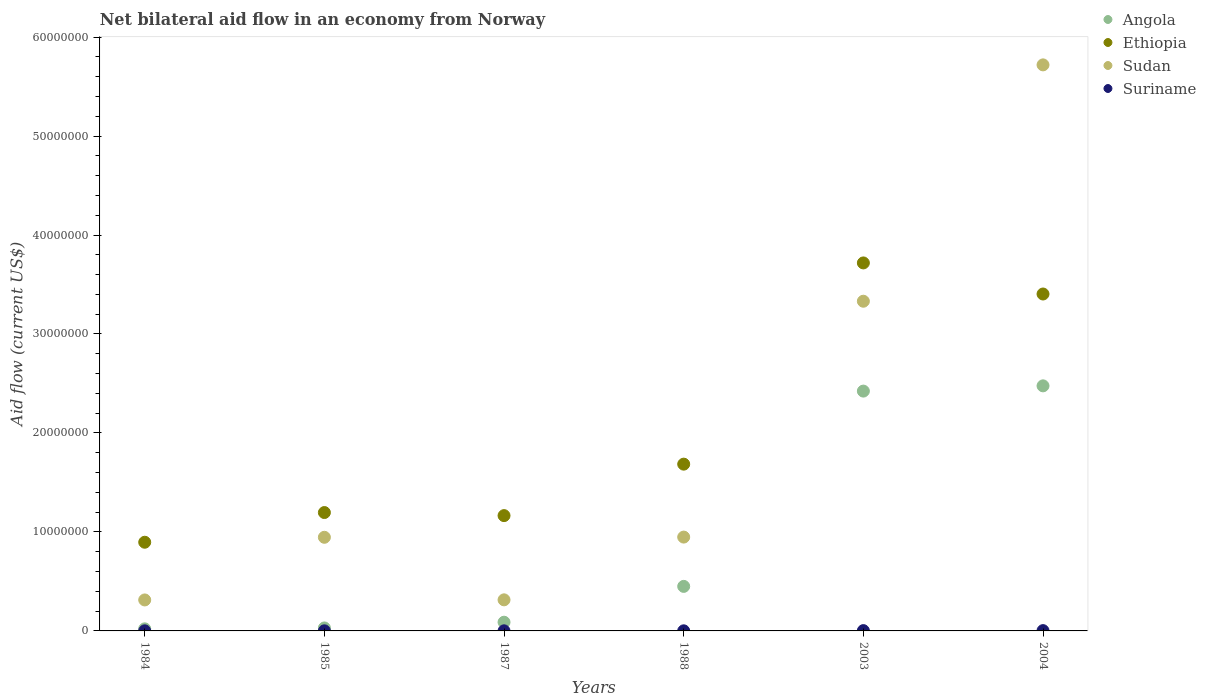How many different coloured dotlines are there?
Ensure brevity in your answer.  4. What is the net bilateral aid flow in Ethiopia in 1988?
Offer a very short reply. 1.68e+07. Across all years, what is the maximum net bilateral aid flow in Suriname?
Your answer should be compact. 3.00e+04. Across all years, what is the minimum net bilateral aid flow in Sudan?
Your response must be concise. 3.13e+06. In which year was the net bilateral aid flow in Ethiopia maximum?
Give a very brief answer. 2003. What is the total net bilateral aid flow in Ethiopia in the graph?
Give a very brief answer. 1.21e+08. What is the difference between the net bilateral aid flow in Suriname in 1984 and that in 1985?
Your answer should be very brief. 0. What is the difference between the net bilateral aid flow in Ethiopia in 2003 and the net bilateral aid flow in Sudan in 1987?
Provide a short and direct response. 3.40e+07. What is the average net bilateral aid flow in Angola per year?
Make the answer very short. 9.15e+06. In the year 2004, what is the difference between the net bilateral aid flow in Ethiopia and net bilateral aid flow in Sudan?
Make the answer very short. -2.32e+07. What is the ratio of the net bilateral aid flow in Sudan in 1984 to that in 1987?
Provide a short and direct response. 1. What is the difference between the highest and the second highest net bilateral aid flow in Angola?
Your response must be concise. 5.30e+05. What is the difference between the highest and the lowest net bilateral aid flow in Suriname?
Your answer should be very brief. 2.00e+04. In how many years, is the net bilateral aid flow in Suriname greater than the average net bilateral aid flow in Suriname taken over all years?
Ensure brevity in your answer.  2. Is it the case that in every year, the sum of the net bilateral aid flow in Sudan and net bilateral aid flow in Angola  is greater than the sum of net bilateral aid flow in Suriname and net bilateral aid flow in Ethiopia?
Your answer should be compact. No. Is it the case that in every year, the sum of the net bilateral aid flow in Suriname and net bilateral aid flow in Sudan  is greater than the net bilateral aid flow in Ethiopia?
Ensure brevity in your answer.  No. Does the net bilateral aid flow in Sudan monotonically increase over the years?
Offer a terse response. No. How many years are there in the graph?
Provide a short and direct response. 6. What is the difference between two consecutive major ticks on the Y-axis?
Your answer should be very brief. 1.00e+07. Are the values on the major ticks of Y-axis written in scientific E-notation?
Your answer should be compact. No. Does the graph contain grids?
Make the answer very short. No. How many legend labels are there?
Your response must be concise. 4. How are the legend labels stacked?
Keep it short and to the point. Vertical. What is the title of the graph?
Give a very brief answer. Net bilateral aid flow in an economy from Norway. Does "Malaysia" appear as one of the legend labels in the graph?
Provide a short and direct response. No. What is the label or title of the Y-axis?
Keep it short and to the point. Aid flow (current US$). What is the Aid flow (current US$) in Ethiopia in 1984?
Your answer should be compact. 8.96e+06. What is the Aid flow (current US$) of Sudan in 1984?
Your response must be concise. 3.13e+06. What is the Aid flow (current US$) in Suriname in 1984?
Provide a succinct answer. 10000. What is the Aid flow (current US$) of Angola in 1985?
Give a very brief answer. 3.00e+05. What is the Aid flow (current US$) of Ethiopia in 1985?
Make the answer very short. 1.20e+07. What is the Aid flow (current US$) in Sudan in 1985?
Your answer should be very brief. 9.46e+06. What is the Aid flow (current US$) in Suriname in 1985?
Make the answer very short. 10000. What is the Aid flow (current US$) of Angola in 1987?
Offer a very short reply. 8.80e+05. What is the Aid flow (current US$) in Ethiopia in 1987?
Keep it short and to the point. 1.16e+07. What is the Aid flow (current US$) of Sudan in 1987?
Make the answer very short. 3.14e+06. What is the Aid flow (current US$) in Suriname in 1987?
Make the answer very short. 10000. What is the Aid flow (current US$) of Angola in 1988?
Offer a terse response. 4.50e+06. What is the Aid flow (current US$) in Ethiopia in 1988?
Your answer should be very brief. 1.68e+07. What is the Aid flow (current US$) in Sudan in 1988?
Your answer should be compact. 9.48e+06. What is the Aid flow (current US$) of Suriname in 1988?
Your answer should be compact. 10000. What is the Aid flow (current US$) in Angola in 2003?
Give a very brief answer. 2.42e+07. What is the Aid flow (current US$) of Ethiopia in 2003?
Keep it short and to the point. 3.72e+07. What is the Aid flow (current US$) of Sudan in 2003?
Offer a terse response. 3.33e+07. What is the Aid flow (current US$) of Suriname in 2003?
Keep it short and to the point. 3.00e+04. What is the Aid flow (current US$) of Angola in 2004?
Your answer should be very brief. 2.48e+07. What is the Aid flow (current US$) in Ethiopia in 2004?
Offer a terse response. 3.40e+07. What is the Aid flow (current US$) in Sudan in 2004?
Ensure brevity in your answer.  5.72e+07. What is the Aid flow (current US$) in Suriname in 2004?
Offer a very short reply. 3.00e+04. Across all years, what is the maximum Aid flow (current US$) of Angola?
Make the answer very short. 2.48e+07. Across all years, what is the maximum Aid flow (current US$) in Ethiopia?
Your answer should be compact. 3.72e+07. Across all years, what is the maximum Aid flow (current US$) in Sudan?
Keep it short and to the point. 5.72e+07. Across all years, what is the minimum Aid flow (current US$) in Ethiopia?
Make the answer very short. 8.96e+06. Across all years, what is the minimum Aid flow (current US$) of Sudan?
Keep it short and to the point. 3.13e+06. What is the total Aid flow (current US$) of Angola in the graph?
Give a very brief answer. 5.49e+07. What is the total Aid flow (current US$) of Ethiopia in the graph?
Offer a very short reply. 1.21e+08. What is the total Aid flow (current US$) in Sudan in the graph?
Make the answer very short. 1.16e+08. What is the difference between the Aid flow (current US$) in Angola in 1984 and that in 1985?
Give a very brief answer. -9.00e+04. What is the difference between the Aid flow (current US$) of Sudan in 1984 and that in 1985?
Provide a succinct answer. -6.33e+06. What is the difference between the Aid flow (current US$) of Angola in 1984 and that in 1987?
Give a very brief answer. -6.70e+05. What is the difference between the Aid flow (current US$) of Ethiopia in 1984 and that in 1987?
Provide a short and direct response. -2.69e+06. What is the difference between the Aid flow (current US$) of Angola in 1984 and that in 1988?
Provide a short and direct response. -4.29e+06. What is the difference between the Aid flow (current US$) in Ethiopia in 1984 and that in 1988?
Offer a very short reply. -7.89e+06. What is the difference between the Aid flow (current US$) in Sudan in 1984 and that in 1988?
Ensure brevity in your answer.  -6.35e+06. What is the difference between the Aid flow (current US$) in Suriname in 1984 and that in 1988?
Provide a succinct answer. 0. What is the difference between the Aid flow (current US$) of Angola in 1984 and that in 2003?
Keep it short and to the point. -2.40e+07. What is the difference between the Aid flow (current US$) of Ethiopia in 1984 and that in 2003?
Make the answer very short. -2.82e+07. What is the difference between the Aid flow (current US$) of Sudan in 1984 and that in 2003?
Offer a terse response. -3.02e+07. What is the difference between the Aid flow (current US$) of Suriname in 1984 and that in 2003?
Make the answer very short. -2.00e+04. What is the difference between the Aid flow (current US$) in Angola in 1984 and that in 2004?
Ensure brevity in your answer.  -2.46e+07. What is the difference between the Aid flow (current US$) of Ethiopia in 1984 and that in 2004?
Give a very brief answer. -2.51e+07. What is the difference between the Aid flow (current US$) of Sudan in 1984 and that in 2004?
Give a very brief answer. -5.41e+07. What is the difference between the Aid flow (current US$) of Suriname in 1984 and that in 2004?
Your response must be concise. -2.00e+04. What is the difference between the Aid flow (current US$) in Angola in 1985 and that in 1987?
Your answer should be compact. -5.80e+05. What is the difference between the Aid flow (current US$) in Sudan in 1985 and that in 1987?
Keep it short and to the point. 6.32e+06. What is the difference between the Aid flow (current US$) of Angola in 1985 and that in 1988?
Provide a succinct answer. -4.20e+06. What is the difference between the Aid flow (current US$) in Ethiopia in 1985 and that in 1988?
Your response must be concise. -4.89e+06. What is the difference between the Aid flow (current US$) in Suriname in 1985 and that in 1988?
Your response must be concise. 0. What is the difference between the Aid flow (current US$) of Angola in 1985 and that in 2003?
Make the answer very short. -2.39e+07. What is the difference between the Aid flow (current US$) of Ethiopia in 1985 and that in 2003?
Your answer should be compact. -2.52e+07. What is the difference between the Aid flow (current US$) of Sudan in 1985 and that in 2003?
Offer a very short reply. -2.38e+07. What is the difference between the Aid flow (current US$) of Suriname in 1985 and that in 2003?
Keep it short and to the point. -2.00e+04. What is the difference between the Aid flow (current US$) in Angola in 1985 and that in 2004?
Ensure brevity in your answer.  -2.45e+07. What is the difference between the Aid flow (current US$) in Ethiopia in 1985 and that in 2004?
Keep it short and to the point. -2.21e+07. What is the difference between the Aid flow (current US$) in Sudan in 1985 and that in 2004?
Your response must be concise. -4.77e+07. What is the difference between the Aid flow (current US$) in Angola in 1987 and that in 1988?
Your answer should be very brief. -3.62e+06. What is the difference between the Aid flow (current US$) in Ethiopia in 1987 and that in 1988?
Provide a succinct answer. -5.20e+06. What is the difference between the Aid flow (current US$) in Sudan in 1987 and that in 1988?
Keep it short and to the point. -6.34e+06. What is the difference between the Aid flow (current US$) of Angola in 1987 and that in 2003?
Provide a short and direct response. -2.34e+07. What is the difference between the Aid flow (current US$) of Ethiopia in 1987 and that in 2003?
Your answer should be compact. -2.55e+07. What is the difference between the Aid flow (current US$) in Sudan in 1987 and that in 2003?
Provide a short and direct response. -3.02e+07. What is the difference between the Aid flow (current US$) in Suriname in 1987 and that in 2003?
Offer a terse response. -2.00e+04. What is the difference between the Aid flow (current US$) of Angola in 1987 and that in 2004?
Keep it short and to the point. -2.39e+07. What is the difference between the Aid flow (current US$) of Ethiopia in 1987 and that in 2004?
Give a very brief answer. -2.24e+07. What is the difference between the Aid flow (current US$) of Sudan in 1987 and that in 2004?
Provide a short and direct response. -5.40e+07. What is the difference between the Aid flow (current US$) of Angola in 1988 and that in 2003?
Make the answer very short. -1.97e+07. What is the difference between the Aid flow (current US$) in Ethiopia in 1988 and that in 2003?
Offer a very short reply. -2.03e+07. What is the difference between the Aid flow (current US$) of Sudan in 1988 and that in 2003?
Make the answer very short. -2.38e+07. What is the difference between the Aid flow (current US$) in Angola in 1988 and that in 2004?
Make the answer very short. -2.03e+07. What is the difference between the Aid flow (current US$) of Ethiopia in 1988 and that in 2004?
Provide a succinct answer. -1.72e+07. What is the difference between the Aid flow (current US$) of Sudan in 1988 and that in 2004?
Provide a succinct answer. -4.77e+07. What is the difference between the Aid flow (current US$) in Angola in 2003 and that in 2004?
Make the answer very short. -5.30e+05. What is the difference between the Aid flow (current US$) of Ethiopia in 2003 and that in 2004?
Your answer should be very brief. 3.14e+06. What is the difference between the Aid flow (current US$) of Sudan in 2003 and that in 2004?
Give a very brief answer. -2.39e+07. What is the difference between the Aid flow (current US$) of Angola in 1984 and the Aid flow (current US$) of Ethiopia in 1985?
Keep it short and to the point. -1.18e+07. What is the difference between the Aid flow (current US$) in Angola in 1984 and the Aid flow (current US$) in Sudan in 1985?
Offer a terse response. -9.25e+06. What is the difference between the Aid flow (current US$) in Angola in 1984 and the Aid flow (current US$) in Suriname in 1985?
Provide a short and direct response. 2.00e+05. What is the difference between the Aid flow (current US$) of Ethiopia in 1984 and the Aid flow (current US$) of Sudan in 1985?
Provide a succinct answer. -5.00e+05. What is the difference between the Aid flow (current US$) of Ethiopia in 1984 and the Aid flow (current US$) of Suriname in 1985?
Provide a short and direct response. 8.95e+06. What is the difference between the Aid flow (current US$) of Sudan in 1984 and the Aid flow (current US$) of Suriname in 1985?
Your answer should be very brief. 3.12e+06. What is the difference between the Aid flow (current US$) in Angola in 1984 and the Aid flow (current US$) in Ethiopia in 1987?
Offer a terse response. -1.14e+07. What is the difference between the Aid flow (current US$) in Angola in 1984 and the Aid flow (current US$) in Sudan in 1987?
Keep it short and to the point. -2.93e+06. What is the difference between the Aid flow (current US$) of Angola in 1984 and the Aid flow (current US$) of Suriname in 1987?
Offer a very short reply. 2.00e+05. What is the difference between the Aid flow (current US$) in Ethiopia in 1984 and the Aid flow (current US$) in Sudan in 1987?
Offer a very short reply. 5.82e+06. What is the difference between the Aid flow (current US$) in Ethiopia in 1984 and the Aid flow (current US$) in Suriname in 1987?
Offer a terse response. 8.95e+06. What is the difference between the Aid flow (current US$) in Sudan in 1984 and the Aid flow (current US$) in Suriname in 1987?
Offer a very short reply. 3.12e+06. What is the difference between the Aid flow (current US$) in Angola in 1984 and the Aid flow (current US$) in Ethiopia in 1988?
Keep it short and to the point. -1.66e+07. What is the difference between the Aid flow (current US$) in Angola in 1984 and the Aid flow (current US$) in Sudan in 1988?
Give a very brief answer. -9.27e+06. What is the difference between the Aid flow (current US$) in Angola in 1984 and the Aid flow (current US$) in Suriname in 1988?
Offer a terse response. 2.00e+05. What is the difference between the Aid flow (current US$) of Ethiopia in 1984 and the Aid flow (current US$) of Sudan in 1988?
Provide a short and direct response. -5.20e+05. What is the difference between the Aid flow (current US$) in Ethiopia in 1984 and the Aid flow (current US$) in Suriname in 1988?
Make the answer very short. 8.95e+06. What is the difference between the Aid flow (current US$) of Sudan in 1984 and the Aid flow (current US$) of Suriname in 1988?
Provide a short and direct response. 3.12e+06. What is the difference between the Aid flow (current US$) in Angola in 1984 and the Aid flow (current US$) in Ethiopia in 2003?
Your answer should be compact. -3.70e+07. What is the difference between the Aid flow (current US$) in Angola in 1984 and the Aid flow (current US$) in Sudan in 2003?
Provide a succinct answer. -3.31e+07. What is the difference between the Aid flow (current US$) of Ethiopia in 1984 and the Aid flow (current US$) of Sudan in 2003?
Offer a very short reply. -2.44e+07. What is the difference between the Aid flow (current US$) of Ethiopia in 1984 and the Aid flow (current US$) of Suriname in 2003?
Offer a very short reply. 8.93e+06. What is the difference between the Aid flow (current US$) in Sudan in 1984 and the Aid flow (current US$) in Suriname in 2003?
Keep it short and to the point. 3.10e+06. What is the difference between the Aid flow (current US$) of Angola in 1984 and the Aid flow (current US$) of Ethiopia in 2004?
Offer a terse response. -3.38e+07. What is the difference between the Aid flow (current US$) of Angola in 1984 and the Aid flow (current US$) of Sudan in 2004?
Make the answer very short. -5.70e+07. What is the difference between the Aid flow (current US$) in Angola in 1984 and the Aid flow (current US$) in Suriname in 2004?
Give a very brief answer. 1.80e+05. What is the difference between the Aid flow (current US$) of Ethiopia in 1984 and the Aid flow (current US$) of Sudan in 2004?
Make the answer very short. -4.82e+07. What is the difference between the Aid flow (current US$) in Ethiopia in 1984 and the Aid flow (current US$) in Suriname in 2004?
Offer a terse response. 8.93e+06. What is the difference between the Aid flow (current US$) of Sudan in 1984 and the Aid flow (current US$) of Suriname in 2004?
Provide a succinct answer. 3.10e+06. What is the difference between the Aid flow (current US$) of Angola in 1985 and the Aid flow (current US$) of Ethiopia in 1987?
Give a very brief answer. -1.14e+07. What is the difference between the Aid flow (current US$) in Angola in 1985 and the Aid flow (current US$) in Sudan in 1987?
Your answer should be compact. -2.84e+06. What is the difference between the Aid flow (current US$) of Ethiopia in 1985 and the Aid flow (current US$) of Sudan in 1987?
Your response must be concise. 8.82e+06. What is the difference between the Aid flow (current US$) in Ethiopia in 1985 and the Aid flow (current US$) in Suriname in 1987?
Provide a short and direct response. 1.20e+07. What is the difference between the Aid flow (current US$) of Sudan in 1985 and the Aid flow (current US$) of Suriname in 1987?
Your answer should be compact. 9.45e+06. What is the difference between the Aid flow (current US$) in Angola in 1985 and the Aid flow (current US$) in Ethiopia in 1988?
Make the answer very short. -1.66e+07. What is the difference between the Aid flow (current US$) in Angola in 1985 and the Aid flow (current US$) in Sudan in 1988?
Provide a succinct answer. -9.18e+06. What is the difference between the Aid flow (current US$) of Ethiopia in 1985 and the Aid flow (current US$) of Sudan in 1988?
Your answer should be compact. 2.48e+06. What is the difference between the Aid flow (current US$) in Ethiopia in 1985 and the Aid flow (current US$) in Suriname in 1988?
Make the answer very short. 1.20e+07. What is the difference between the Aid flow (current US$) in Sudan in 1985 and the Aid flow (current US$) in Suriname in 1988?
Make the answer very short. 9.45e+06. What is the difference between the Aid flow (current US$) in Angola in 1985 and the Aid flow (current US$) in Ethiopia in 2003?
Your response must be concise. -3.69e+07. What is the difference between the Aid flow (current US$) in Angola in 1985 and the Aid flow (current US$) in Sudan in 2003?
Keep it short and to the point. -3.30e+07. What is the difference between the Aid flow (current US$) in Angola in 1985 and the Aid flow (current US$) in Suriname in 2003?
Your answer should be very brief. 2.70e+05. What is the difference between the Aid flow (current US$) of Ethiopia in 1985 and the Aid flow (current US$) of Sudan in 2003?
Offer a terse response. -2.14e+07. What is the difference between the Aid flow (current US$) of Ethiopia in 1985 and the Aid flow (current US$) of Suriname in 2003?
Offer a terse response. 1.19e+07. What is the difference between the Aid flow (current US$) in Sudan in 1985 and the Aid flow (current US$) in Suriname in 2003?
Your response must be concise. 9.43e+06. What is the difference between the Aid flow (current US$) of Angola in 1985 and the Aid flow (current US$) of Ethiopia in 2004?
Ensure brevity in your answer.  -3.37e+07. What is the difference between the Aid flow (current US$) in Angola in 1985 and the Aid flow (current US$) in Sudan in 2004?
Make the answer very short. -5.69e+07. What is the difference between the Aid flow (current US$) in Ethiopia in 1985 and the Aid flow (current US$) in Sudan in 2004?
Make the answer very short. -4.52e+07. What is the difference between the Aid flow (current US$) in Ethiopia in 1985 and the Aid flow (current US$) in Suriname in 2004?
Give a very brief answer. 1.19e+07. What is the difference between the Aid flow (current US$) of Sudan in 1985 and the Aid flow (current US$) of Suriname in 2004?
Keep it short and to the point. 9.43e+06. What is the difference between the Aid flow (current US$) of Angola in 1987 and the Aid flow (current US$) of Ethiopia in 1988?
Your response must be concise. -1.60e+07. What is the difference between the Aid flow (current US$) of Angola in 1987 and the Aid flow (current US$) of Sudan in 1988?
Make the answer very short. -8.60e+06. What is the difference between the Aid flow (current US$) of Angola in 1987 and the Aid flow (current US$) of Suriname in 1988?
Make the answer very short. 8.70e+05. What is the difference between the Aid flow (current US$) in Ethiopia in 1987 and the Aid flow (current US$) in Sudan in 1988?
Your answer should be compact. 2.17e+06. What is the difference between the Aid flow (current US$) of Ethiopia in 1987 and the Aid flow (current US$) of Suriname in 1988?
Give a very brief answer. 1.16e+07. What is the difference between the Aid flow (current US$) of Sudan in 1987 and the Aid flow (current US$) of Suriname in 1988?
Keep it short and to the point. 3.13e+06. What is the difference between the Aid flow (current US$) of Angola in 1987 and the Aid flow (current US$) of Ethiopia in 2003?
Offer a terse response. -3.63e+07. What is the difference between the Aid flow (current US$) of Angola in 1987 and the Aid flow (current US$) of Sudan in 2003?
Provide a succinct answer. -3.24e+07. What is the difference between the Aid flow (current US$) of Angola in 1987 and the Aid flow (current US$) of Suriname in 2003?
Your answer should be compact. 8.50e+05. What is the difference between the Aid flow (current US$) in Ethiopia in 1987 and the Aid flow (current US$) in Sudan in 2003?
Your response must be concise. -2.17e+07. What is the difference between the Aid flow (current US$) of Ethiopia in 1987 and the Aid flow (current US$) of Suriname in 2003?
Your response must be concise. 1.16e+07. What is the difference between the Aid flow (current US$) of Sudan in 1987 and the Aid flow (current US$) of Suriname in 2003?
Your answer should be very brief. 3.11e+06. What is the difference between the Aid flow (current US$) of Angola in 1987 and the Aid flow (current US$) of Ethiopia in 2004?
Give a very brief answer. -3.32e+07. What is the difference between the Aid flow (current US$) in Angola in 1987 and the Aid flow (current US$) in Sudan in 2004?
Ensure brevity in your answer.  -5.63e+07. What is the difference between the Aid flow (current US$) of Angola in 1987 and the Aid flow (current US$) of Suriname in 2004?
Offer a very short reply. 8.50e+05. What is the difference between the Aid flow (current US$) of Ethiopia in 1987 and the Aid flow (current US$) of Sudan in 2004?
Your response must be concise. -4.55e+07. What is the difference between the Aid flow (current US$) of Ethiopia in 1987 and the Aid flow (current US$) of Suriname in 2004?
Your answer should be very brief. 1.16e+07. What is the difference between the Aid flow (current US$) of Sudan in 1987 and the Aid flow (current US$) of Suriname in 2004?
Keep it short and to the point. 3.11e+06. What is the difference between the Aid flow (current US$) in Angola in 1988 and the Aid flow (current US$) in Ethiopia in 2003?
Ensure brevity in your answer.  -3.27e+07. What is the difference between the Aid flow (current US$) in Angola in 1988 and the Aid flow (current US$) in Sudan in 2003?
Your answer should be very brief. -2.88e+07. What is the difference between the Aid flow (current US$) in Angola in 1988 and the Aid flow (current US$) in Suriname in 2003?
Offer a terse response. 4.47e+06. What is the difference between the Aid flow (current US$) of Ethiopia in 1988 and the Aid flow (current US$) of Sudan in 2003?
Provide a short and direct response. -1.65e+07. What is the difference between the Aid flow (current US$) in Ethiopia in 1988 and the Aid flow (current US$) in Suriname in 2003?
Offer a terse response. 1.68e+07. What is the difference between the Aid flow (current US$) in Sudan in 1988 and the Aid flow (current US$) in Suriname in 2003?
Your answer should be very brief. 9.45e+06. What is the difference between the Aid flow (current US$) of Angola in 1988 and the Aid flow (current US$) of Ethiopia in 2004?
Provide a short and direct response. -2.95e+07. What is the difference between the Aid flow (current US$) in Angola in 1988 and the Aid flow (current US$) in Sudan in 2004?
Keep it short and to the point. -5.27e+07. What is the difference between the Aid flow (current US$) of Angola in 1988 and the Aid flow (current US$) of Suriname in 2004?
Give a very brief answer. 4.47e+06. What is the difference between the Aid flow (current US$) in Ethiopia in 1988 and the Aid flow (current US$) in Sudan in 2004?
Ensure brevity in your answer.  -4.03e+07. What is the difference between the Aid flow (current US$) in Ethiopia in 1988 and the Aid flow (current US$) in Suriname in 2004?
Keep it short and to the point. 1.68e+07. What is the difference between the Aid flow (current US$) in Sudan in 1988 and the Aid flow (current US$) in Suriname in 2004?
Provide a succinct answer. 9.45e+06. What is the difference between the Aid flow (current US$) in Angola in 2003 and the Aid flow (current US$) in Ethiopia in 2004?
Ensure brevity in your answer.  -9.81e+06. What is the difference between the Aid flow (current US$) in Angola in 2003 and the Aid flow (current US$) in Sudan in 2004?
Keep it short and to the point. -3.30e+07. What is the difference between the Aid flow (current US$) of Angola in 2003 and the Aid flow (current US$) of Suriname in 2004?
Ensure brevity in your answer.  2.42e+07. What is the difference between the Aid flow (current US$) of Ethiopia in 2003 and the Aid flow (current US$) of Sudan in 2004?
Offer a very short reply. -2.00e+07. What is the difference between the Aid flow (current US$) in Ethiopia in 2003 and the Aid flow (current US$) in Suriname in 2004?
Your response must be concise. 3.72e+07. What is the difference between the Aid flow (current US$) in Sudan in 2003 and the Aid flow (current US$) in Suriname in 2004?
Give a very brief answer. 3.33e+07. What is the average Aid flow (current US$) of Angola per year?
Offer a very short reply. 9.15e+06. What is the average Aid flow (current US$) in Ethiopia per year?
Your response must be concise. 2.01e+07. What is the average Aid flow (current US$) of Sudan per year?
Make the answer very short. 1.93e+07. What is the average Aid flow (current US$) in Suriname per year?
Give a very brief answer. 1.67e+04. In the year 1984, what is the difference between the Aid flow (current US$) of Angola and Aid flow (current US$) of Ethiopia?
Your response must be concise. -8.75e+06. In the year 1984, what is the difference between the Aid flow (current US$) of Angola and Aid flow (current US$) of Sudan?
Give a very brief answer. -2.92e+06. In the year 1984, what is the difference between the Aid flow (current US$) in Angola and Aid flow (current US$) in Suriname?
Your response must be concise. 2.00e+05. In the year 1984, what is the difference between the Aid flow (current US$) in Ethiopia and Aid flow (current US$) in Sudan?
Provide a short and direct response. 5.83e+06. In the year 1984, what is the difference between the Aid flow (current US$) in Ethiopia and Aid flow (current US$) in Suriname?
Provide a succinct answer. 8.95e+06. In the year 1984, what is the difference between the Aid flow (current US$) in Sudan and Aid flow (current US$) in Suriname?
Make the answer very short. 3.12e+06. In the year 1985, what is the difference between the Aid flow (current US$) in Angola and Aid flow (current US$) in Ethiopia?
Your response must be concise. -1.17e+07. In the year 1985, what is the difference between the Aid flow (current US$) of Angola and Aid flow (current US$) of Sudan?
Make the answer very short. -9.16e+06. In the year 1985, what is the difference between the Aid flow (current US$) of Angola and Aid flow (current US$) of Suriname?
Provide a short and direct response. 2.90e+05. In the year 1985, what is the difference between the Aid flow (current US$) in Ethiopia and Aid flow (current US$) in Sudan?
Provide a short and direct response. 2.50e+06. In the year 1985, what is the difference between the Aid flow (current US$) of Ethiopia and Aid flow (current US$) of Suriname?
Give a very brief answer. 1.20e+07. In the year 1985, what is the difference between the Aid flow (current US$) of Sudan and Aid flow (current US$) of Suriname?
Your answer should be compact. 9.45e+06. In the year 1987, what is the difference between the Aid flow (current US$) in Angola and Aid flow (current US$) in Ethiopia?
Make the answer very short. -1.08e+07. In the year 1987, what is the difference between the Aid flow (current US$) of Angola and Aid flow (current US$) of Sudan?
Offer a very short reply. -2.26e+06. In the year 1987, what is the difference between the Aid flow (current US$) in Angola and Aid flow (current US$) in Suriname?
Provide a short and direct response. 8.70e+05. In the year 1987, what is the difference between the Aid flow (current US$) of Ethiopia and Aid flow (current US$) of Sudan?
Offer a terse response. 8.51e+06. In the year 1987, what is the difference between the Aid flow (current US$) in Ethiopia and Aid flow (current US$) in Suriname?
Provide a succinct answer. 1.16e+07. In the year 1987, what is the difference between the Aid flow (current US$) in Sudan and Aid flow (current US$) in Suriname?
Give a very brief answer. 3.13e+06. In the year 1988, what is the difference between the Aid flow (current US$) in Angola and Aid flow (current US$) in Ethiopia?
Your response must be concise. -1.24e+07. In the year 1988, what is the difference between the Aid flow (current US$) of Angola and Aid flow (current US$) of Sudan?
Offer a very short reply. -4.98e+06. In the year 1988, what is the difference between the Aid flow (current US$) of Angola and Aid flow (current US$) of Suriname?
Your answer should be very brief. 4.49e+06. In the year 1988, what is the difference between the Aid flow (current US$) in Ethiopia and Aid flow (current US$) in Sudan?
Keep it short and to the point. 7.37e+06. In the year 1988, what is the difference between the Aid flow (current US$) in Ethiopia and Aid flow (current US$) in Suriname?
Give a very brief answer. 1.68e+07. In the year 1988, what is the difference between the Aid flow (current US$) in Sudan and Aid flow (current US$) in Suriname?
Give a very brief answer. 9.47e+06. In the year 2003, what is the difference between the Aid flow (current US$) in Angola and Aid flow (current US$) in Ethiopia?
Provide a succinct answer. -1.30e+07. In the year 2003, what is the difference between the Aid flow (current US$) in Angola and Aid flow (current US$) in Sudan?
Keep it short and to the point. -9.08e+06. In the year 2003, what is the difference between the Aid flow (current US$) in Angola and Aid flow (current US$) in Suriname?
Your answer should be very brief. 2.42e+07. In the year 2003, what is the difference between the Aid flow (current US$) of Ethiopia and Aid flow (current US$) of Sudan?
Provide a short and direct response. 3.87e+06. In the year 2003, what is the difference between the Aid flow (current US$) in Ethiopia and Aid flow (current US$) in Suriname?
Your answer should be very brief. 3.72e+07. In the year 2003, what is the difference between the Aid flow (current US$) in Sudan and Aid flow (current US$) in Suriname?
Your answer should be very brief. 3.33e+07. In the year 2004, what is the difference between the Aid flow (current US$) of Angola and Aid flow (current US$) of Ethiopia?
Provide a short and direct response. -9.28e+06. In the year 2004, what is the difference between the Aid flow (current US$) in Angola and Aid flow (current US$) in Sudan?
Provide a succinct answer. -3.24e+07. In the year 2004, what is the difference between the Aid flow (current US$) in Angola and Aid flow (current US$) in Suriname?
Offer a very short reply. 2.47e+07. In the year 2004, what is the difference between the Aid flow (current US$) of Ethiopia and Aid flow (current US$) of Sudan?
Keep it short and to the point. -2.32e+07. In the year 2004, what is the difference between the Aid flow (current US$) of Ethiopia and Aid flow (current US$) of Suriname?
Keep it short and to the point. 3.40e+07. In the year 2004, what is the difference between the Aid flow (current US$) of Sudan and Aid flow (current US$) of Suriname?
Make the answer very short. 5.72e+07. What is the ratio of the Aid flow (current US$) of Angola in 1984 to that in 1985?
Give a very brief answer. 0.7. What is the ratio of the Aid flow (current US$) in Ethiopia in 1984 to that in 1985?
Keep it short and to the point. 0.75. What is the ratio of the Aid flow (current US$) of Sudan in 1984 to that in 1985?
Your answer should be compact. 0.33. What is the ratio of the Aid flow (current US$) in Suriname in 1984 to that in 1985?
Give a very brief answer. 1. What is the ratio of the Aid flow (current US$) in Angola in 1984 to that in 1987?
Offer a terse response. 0.24. What is the ratio of the Aid flow (current US$) in Ethiopia in 1984 to that in 1987?
Provide a short and direct response. 0.77. What is the ratio of the Aid flow (current US$) of Suriname in 1984 to that in 1987?
Your answer should be very brief. 1. What is the ratio of the Aid flow (current US$) in Angola in 1984 to that in 1988?
Offer a terse response. 0.05. What is the ratio of the Aid flow (current US$) in Ethiopia in 1984 to that in 1988?
Offer a terse response. 0.53. What is the ratio of the Aid flow (current US$) of Sudan in 1984 to that in 1988?
Offer a very short reply. 0.33. What is the ratio of the Aid flow (current US$) in Angola in 1984 to that in 2003?
Provide a short and direct response. 0.01. What is the ratio of the Aid flow (current US$) in Ethiopia in 1984 to that in 2003?
Offer a very short reply. 0.24. What is the ratio of the Aid flow (current US$) of Sudan in 1984 to that in 2003?
Your answer should be compact. 0.09. What is the ratio of the Aid flow (current US$) of Suriname in 1984 to that in 2003?
Offer a very short reply. 0.33. What is the ratio of the Aid flow (current US$) of Angola in 1984 to that in 2004?
Offer a very short reply. 0.01. What is the ratio of the Aid flow (current US$) in Ethiopia in 1984 to that in 2004?
Keep it short and to the point. 0.26. What is the ratio of the Aid flow (current US$) in Sudan in 1984 to that in 2004?
Your response must be concise. 0.05. What is the ratio of the Aid flow (current US$) in Angola in 1985 to that in 1987?
Make the answer very short. 0.34. What is the ratio of the Aid flow (current US$) of Ethiopia in 1985 to that in 1987?
Provide a succinct answer. 1.03. What is the ratio of the Aid flow (current US$) in Sudan in 1985 to that in 1987?
Ensure brevity in your answer.  3.01. What is the ratio of the Aid flow (current US$) in Angola in 1985 to that in 1988?
Provide a succinct answer. 0.07. What is the ratio of the Aid flow (current US$) in Ethiopia in 1985 to that in 1988?
Provide a succinct answer. 0.71. What is the ratio of the Aid flow (current US$) in Angola in 1985 to that in 2003?
Make the answer very short. 0.01. What is the ratio of the Aid flow (current US$) of Ethiopia in 1985 to that in 2003?
Your answer should be very brief. 0.32. What is the ratio of the Aid flow (current US$) of Sudan in 1985 to that in 2003?
Your response must be concise. 0.28. What is the ratio of the Aid flow (current US$) in Angola in 1985 to that in 2004?
Keep it short and to the point. 0.01. What is the ratio of the Aid flow (current US$) of Ethiopia in 1985 to that in 2004?
Your answer should be compact. 0.35. What is the ratio of the Aid flow (current US$) of Sudan in 1985 to that in 2004?
Your response must be concise. 0.17. What is the ratio of the Aid flow (current US$) in Angola in 1987 to that in 1988?
Make the answer very short. 0.2. What is the ratio of the Aid flow (current US$) of Ethiopia in 1987 to that in 1988?
Provide a succinct answer. 0.69. What is the ratio of the Aid flow (current US$) in Sudan in 1987 to that in 1988?
Keep it short and to the point. 0.33. What is the ratio of the Aid flow (current US$) of Suriname in 1987 to that in 1988?
Ensure brevity in your answer.  1. What is the ratio of the Aid flow (current US$) in Angola in 1987 to that in 2003?
Keep it short and to the point. 0.04. What is the ratio of the Aid flow (current US$) in Ethiopia in 1987 to that in 2003?
Offer a terse response. 0.31. What is the ratio of the Aid flow (current US$) of Sudan in 1987 to that in 2003?
Offer a terse response. 0.09. What is the ratio of the Aid flow (current US$) in Suriname in 1987 to that in 2003?
Give a very brief answer. 0.33. What is the ratio of the Aid flow (current US$) in Angola in 1987 to that in 2004?
Provide a succinct answer. 0.04. What is the ratio of the Aid flow (current US$) in Ethiopia in 1987 to that in 2004?
Provide a succinct answer. 0.34. What is the ratio of the Aid flow (current US$) in Sudan in 1987 to that in 2004?
Ensure brevity in your answer.  0.05. What is the ratio of the Aid flow (current US$) of Angola in 1988 to that in 2003?
Ensure brevity in your answer.  0.19. What is the ratio of the Aid flow (current US$) of Ethiopia in 1988 to that in 2003?
Your response must be concise. 0.45. What is the ratio of the Aid flow (current US$) in Sudan in 1988 to that in 2003?
Ensure brevity in your answer.  0.28. What is the ratio of the Aid flow (current US$) in Angola in 1988 to that in 2004?
Provide a short and direct response. 0.18. What is the ratio of the Aid flow (current US$) of Ethiopia in 1988 to that in 2004?
Your response must be concise. 0.49. What is the ratio of the Aid flow (current US$) in Sudan in 1988 to that in 2004?
Provide a succinct answer. 0.17. What is the ratio of the Aid flow (current US$) in Suriname in 1988 to that in 2004?
Ensure brevity in your answer.  0.33. What is the ratio of the Aid flow (current US$) of Angola in 2003 to that in 2004?
Provide a short and direct response. 0.98. What is the ratio of the Aid flow (current US$) in Ethiopia in 2003 to that in 2004?
Give a very brief answer. 1.09. What is the ratio of the Aid flow (current US$) of Sudan in 2003 to that in 2004?
Ensure brevity in your answer.  0.58. What is the difference between the highest and the second highest Aid flow (current US$) in Angola?
Offer a very short reply. 5.30e+05. What is the difference between the highest and the second highest Aid flow (current US$) in Ethiopia?
Offer a terse response. 3.14e+06. What is the difference between the highest and the second highest Aid flow (current US$) in Sudan?
Make the answer very short. 2.39e+07. What is the difference between the highest and the lowest Aid flow (current US$) of Angola?
Keep it short and to the point. 2.46e+07. What is the difference between the highest and the lowest Aid flow (current US$) in Ethiopia?
Offer a terse response. 2.82e+07. What is the difference between the highest and the lowest Aid flow (current US$) in Sudan?
Ensure brevity in your answer.  5.41e+07. What is the difference between the highest and the lowest Aid flow (current US$) of Suriname?
Keep it short and to the point. 2.00e+04. 